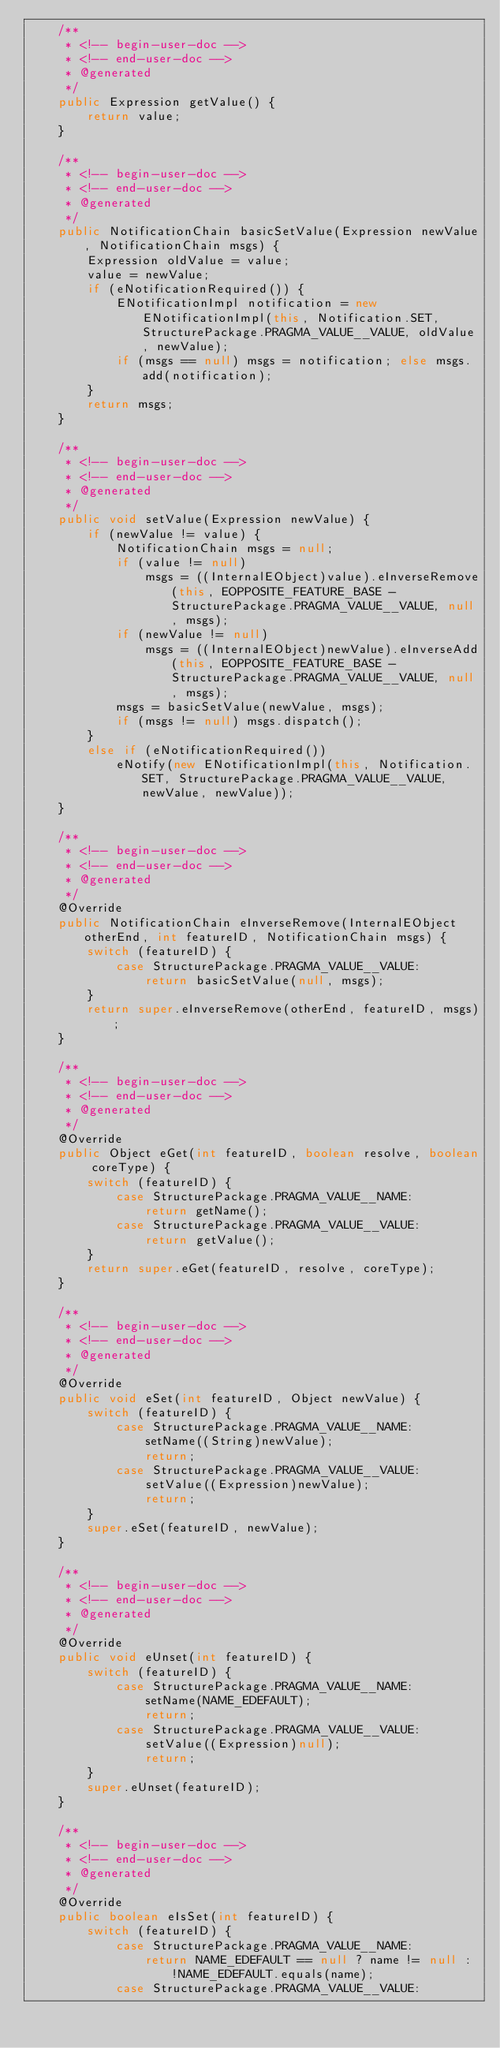Convert code to text. <code><loc_0><loc_0><loc_500><loc_500><_Java_>	/**
	 * <!-- begin-user-doc -->
	 * <!-- end-user-doc -->
	 * @generated
	 */
	public Expression getValue() {
		return value;
	}

	/**
	 * <!-- begin-user-doc -->
	 * <!-- end-user-doc -->
	 * @generated
	 */
	public NotificationChain basicSetValue(Expression newValue, NotificationChain msgs) {
		Expression oldValue = value;
		value = newValue;
		if (eNotificationRequired()) {
			ENotificationImpl notification = new ENotificationImpl(this, Notification.SET, StructurePackage.PRAGMA_VALUE__VALUE, oldValue, newValue);
			if (msgs == null) msgs = notification; else msgs.add(notification);
		}
		return msgs;
	}

	/**
	 * <!-- begin-user-doc -->
	 * <!-- end-user-doc -->
	 * @generated
	 */
	public void setValue(Expression newValue) {
		if (newValue != value) {
			NotificationChain msgs = null;
			if (value != null)
				msgs = ((InternalEObject)value).eInverseRemove(this, EOPPOSITE_FEATURE_BASE - StructurePackage.PRAGMA_VALUE__VALUE, null, msgs);
			if (newValue != null)
				msgs = ((InternalEObject)newValue).eInverseAdd(this, EOPPOSITE_FEATURE_BASE - StructurePackage.PRAGMA_VALUE__VALUE, null, msgs);
			msgs = basicSetValue(newValue, msgs);
			if (msgs != null) msgs.dispatch();
		}
		else if (eNotificationRequired())
			eNotify(new ENotificationImpl(this, Notification.SET, StructurePackage.PRAGMA_VALUE__VALUE, newValue, newValue));
	}

	/**
	 * <!-- begin-user-doc -->
	 * <!-- end-user-doc -->
	 * @generated
	 */
	@Override
	public NotificationChain eInverseRemove(InternalEObject otherEnd, int featureID, NotificationChain msgs) {
		switch (featureID) {
			case StructurePackage.PRAGMA_VALUE__VALUE:
				return basicSetValue(null, msgs);
		}
		return super.eInverseRemove(otherEnd, featureID, msgs);
	}

	/**
	 * <!-- begin-user-doc -->
	 * <!-- end-user-doc -->
	 * @generated
	 */
	@Override
	public Object eGet(int featureID, boolean resolve, boolean coreType) {
		switch (featureID) {
			case StructurePackage.PRAGMA_VALUE__NAME:
				return getName();
			case StructurePackage.PRAGMA_VALUE__VALUE:
				return getValue();
		}
		return super.eGet(featureID, resolve, coreType);
	}

	/**
	 * <!-- begin-user-doc -->
	 * <!-- end-user-doc -->
	 * @generated
	 */
	@Override
	public void eSet(int featureID, Object newValue) {
		switch (featureID) {
			case StructurePackage.PRAGMA_VALUE__NAME:
				setName((String)newValue);
				return;
			case StructurePackage.PRAGMA_VALUE__VALUE:
				setValue((Expression)newValue);
				return;
		}
		super.eSet(featureID, newValue);
	}

	/**
	 * <!-- begin-user-doc -->
	 * <!-- end-user-doc -->
	 * @generated
	 */
	@Override
	public void eUnset(int featureID) {
		switch (featureID) {
			case StructurePackage.PRAGMA_VALUE__NAME:
				setName(NAME_EDEFAULT);
				return;
			case StructurePackage.PRAGMA_VALUE__VALUE:
				setValue((Expression)null);
				return;
		}
		super.eUnset(featureID);
	}

	/**
	 * <!-- begin-user-doc -->
	 * <!-- end-user-doc -->
	 * @generated
	 */
	@Override
	public boolean eIsSet(int featureID) {
		switch (featureID) {
			case StructurePackage.PRAGMA_VALUE__NAME:
				return NAME_EDEFAULT == null ? name != null : !NAME_EDEFAULT.equals(name);
			case StructurePackage.PRAGMA_VALUE__VALUE:</code> 